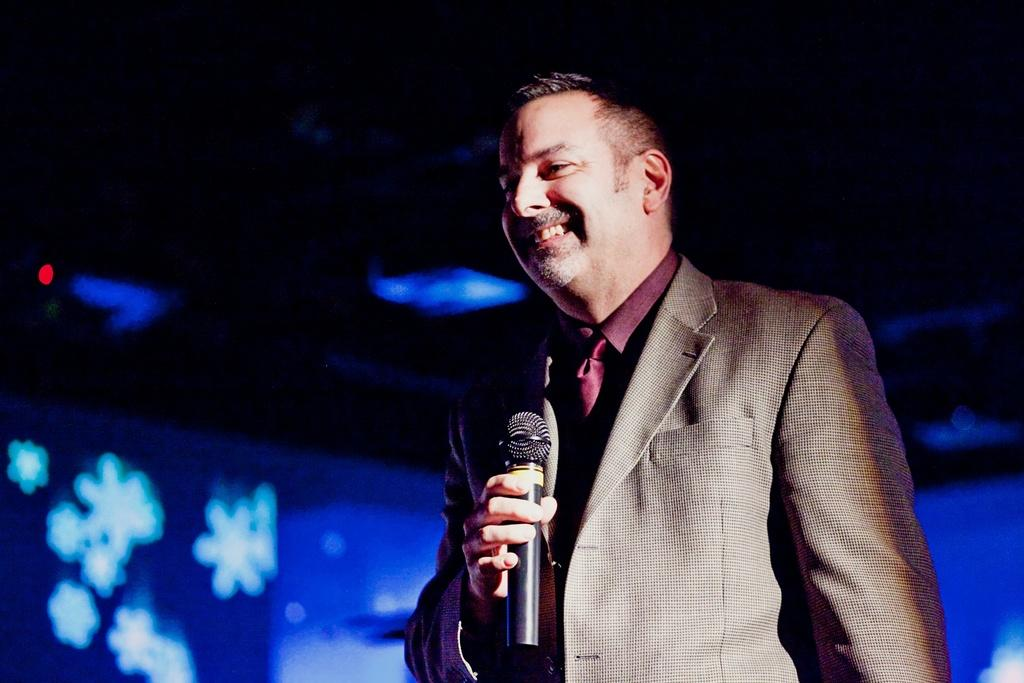What is the person in the image doing? The person is standing on a stage and holding a microphone. What is the person's expression in the image? The person is smiling. What can be seen in the background of the image? There is a blue color decoration part and lights visible in the background. What arithmetic problem is the person solving on stage? There is no indication in the image that the person is solving an arithmetic problem; they are simply holding a microphone and smiling. What thrilling activity is the person participating in on stage? The image does not depict any thrilling activity; the person is standing on a stage and holding a microphone. 